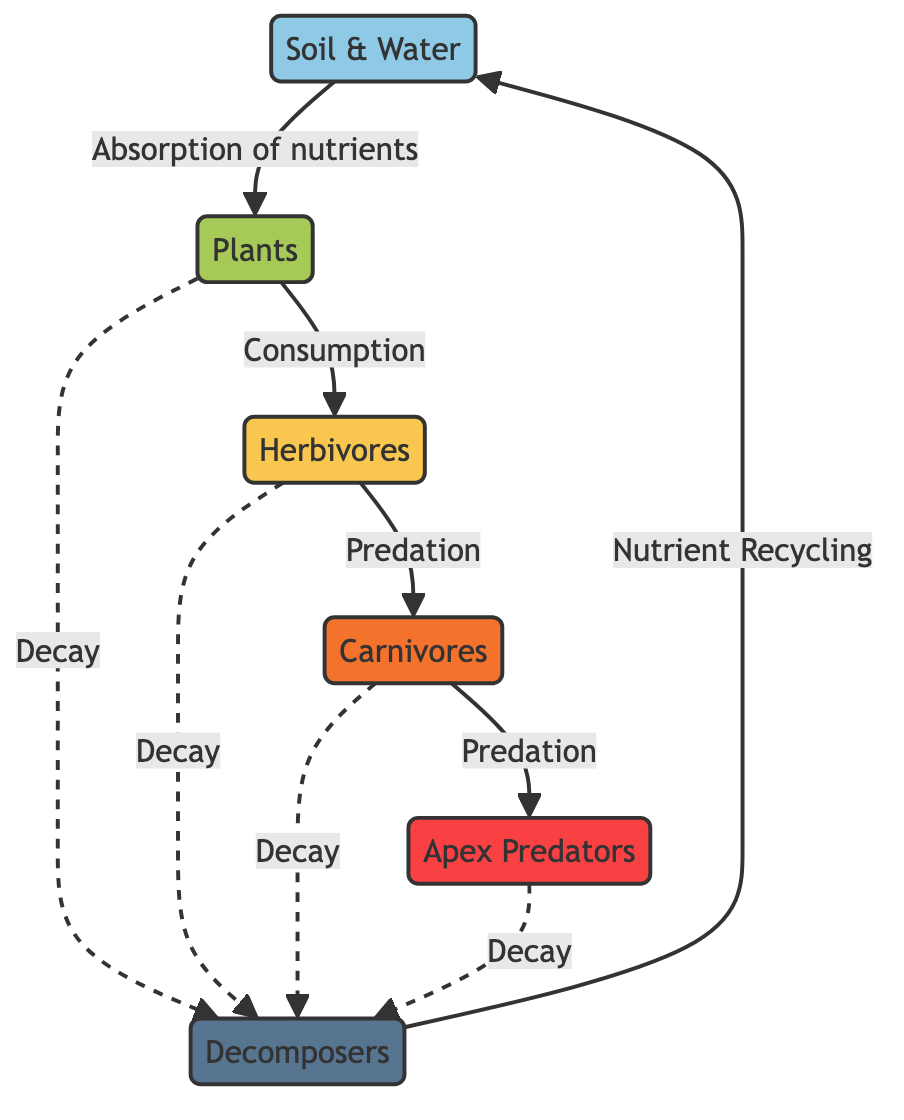What are the initial sources of nutrients in the food web? The diagram indicates that the initial sources of nutrients are "Soil & Water." This is clearly shown as the starting point of the nutrient flow represented by the arrow pointing towards "Plants."
Answer: Soil & Water Which organisms are classified as apex predators in the food web? In the diagram, "Apex Predators" is clearly labeled as a separate node, indicating these organisms occupy the topmost position in the food chain, following "Carnivores."
Answer: Apex Predators How many types of organisms are involved in the nutrient cycle depicted? The diagram includes five types of organisms: "Plants," "Herbivores," "Carnivores," "Apex Predators," and "Decomposers," which can be counted directly from the nodes without overlapping.
Answer: Five What is the relationship between plants and herbivores according to the diagram? The diagram shows an arrow from "Plants" to "Herbivores" labeled "Consumption." This indicates a direct feeding relationship where herbivores consume plants for nutrients.
Answer: Consumption What process returns nutrients back to the soil? The diagram clearly states that "Decomposers" are responsible for "Nutrient Recycling," which implies they break down organic matter and return nutrients to the soil, completing the cycle.
Answer: Nutrient Recycling Explain the role of decomposition in the food web. The diagram illustrates that "Decomposers" receive input from all trophic levels (Plants, Herbivores, Carnivores, and Apex Predators) as indicated by the dashed arrows leading to them labeled "Decay." This shows that when organisms decay, decomposers recycle the nutrients back to "Soil & Water."
Answer: Decomposition recycles nutrients What is the connection between apex predators and decomposers? The connection is shown through the dashed arrow labeled "Decay," which indicates that apex predators contribute organic matter to decomposers after their death, allowing for nutrient cycling back to soil and water.
Answer: Decay What is the flow of nutrients from plants to apex predators? The flow is outlined as follows: "Plants" are consumed by "Herbivores," which are then consumed by "Carnivores," and finally, "Carnivores" are preyed upon by "Apex Predators," indicating a direct food chain progression.
Answer: Plants → Herbivores → Carnivores → Apex Predators What kind of processes are highlighted in the diagram? The diagram illustrates two types of processes: "Consumption" throughout the food chain and "Nutrient Recycling" performed by decomposers. These processes demonstrate the flow of energy and matter in the ecosystem.
Answer: Consumption and Nutrient Recycling 